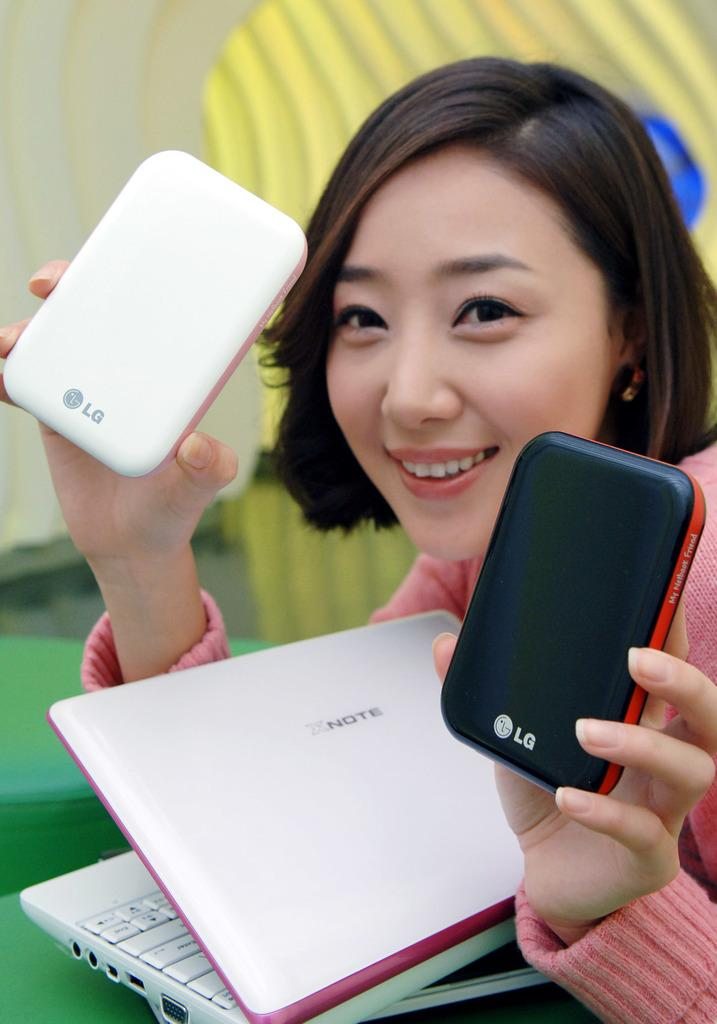<image>
Offer a succinct explanation of the picture presented. An Asian lady is holding two LG phones and has a white XNote lap top too. 